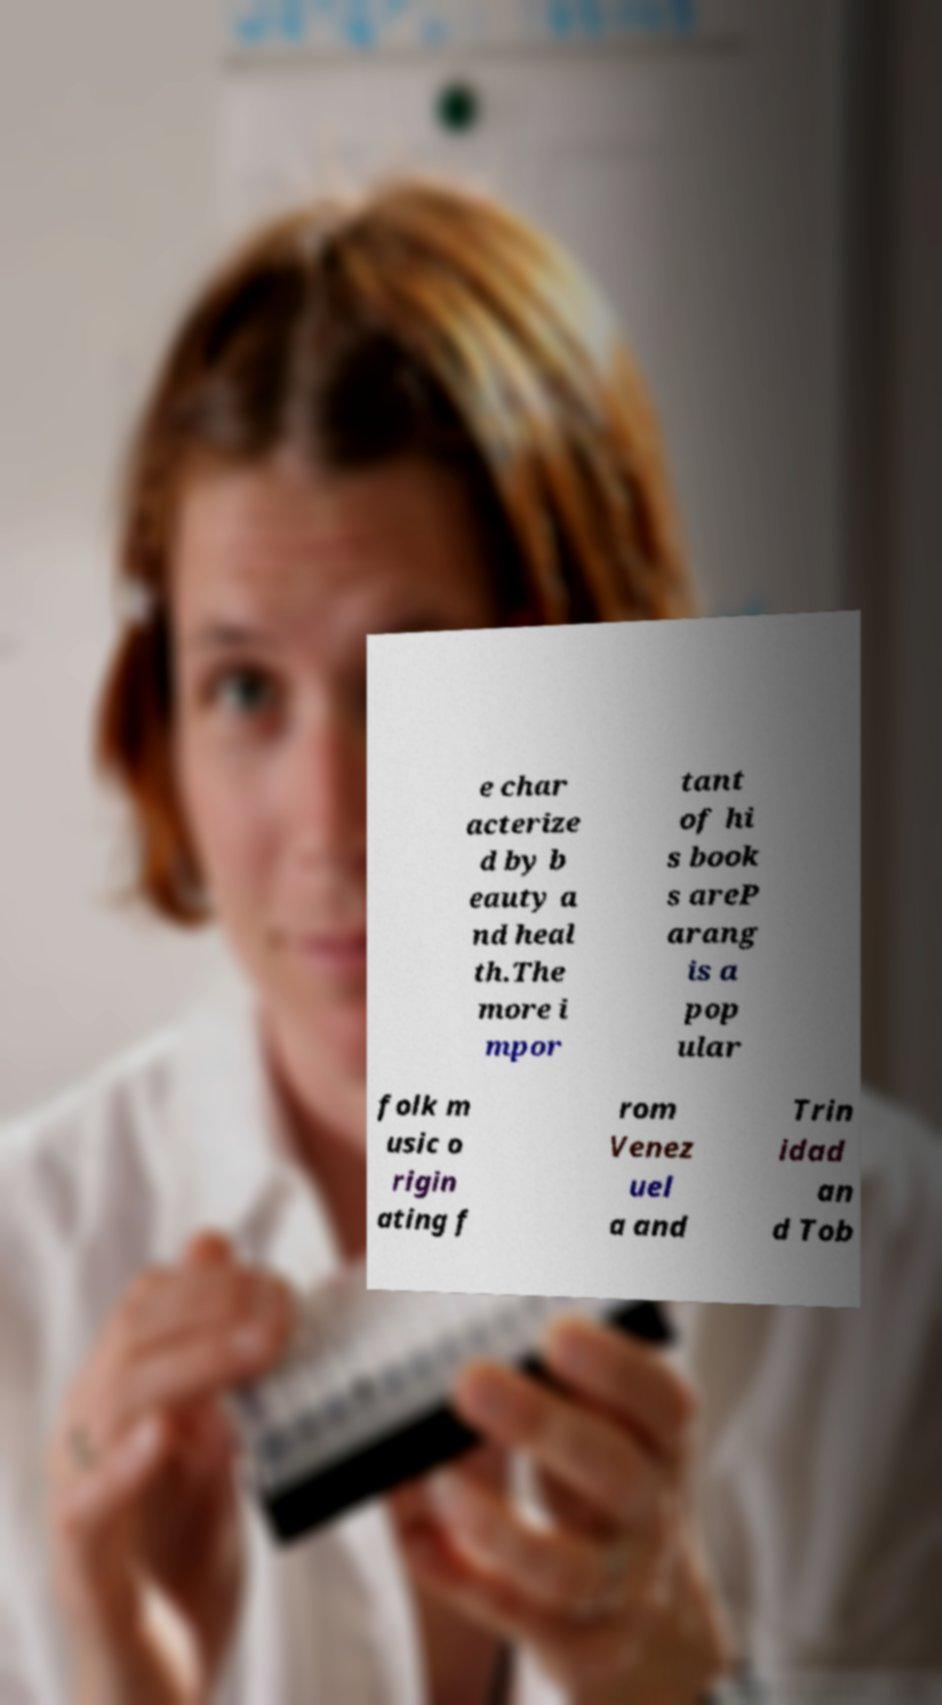There's text embedded in this image that I need extracted. Can you transcribe it verbatim? e char acterize d by b eauty a nd heal th.The more i mpor tant of hi s book s areP arang is a pop ular folk m usic o rigin ating f rom Venez uel a and Trin idad an d Tob 